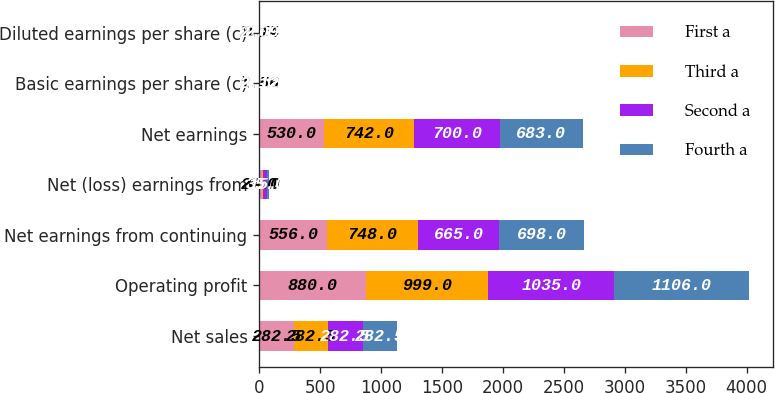<chart> <loc_0><loc_0><loc_500><loc_500><stacked_bar_chart><ecel><fcel>Net sales<fcel>Operating profit<fcel>Net earnings from continuing<fcel>Net (loss) earnings from<fcel>Net earnings<fcel>Basic earnings per share (c)<fcel>Diluted earnings per share (c)<nl><fcel>First a<fcel>282.5<fcel>880<fcel>556<fcel>26<fcel>530<fcel>1.52<fcel>1.5<nl><fcel>Third a<fcel>282.5<fcel>999<fcel>748<fcel>6<fcel>742<fcel>2.16<fcel>2.14<nl><fcel>Second a<fcel>282.5<fcel>1035<fcel>665<fcel>35<fcel>700<fcel>2.12<fcel>2.1<nl><fcel>Fourth a<fcel>282.5<fcel>1106<fcel>698<fcel>15<fcel>683<fcel>2.12<fcel>2.09<nl></chart> 